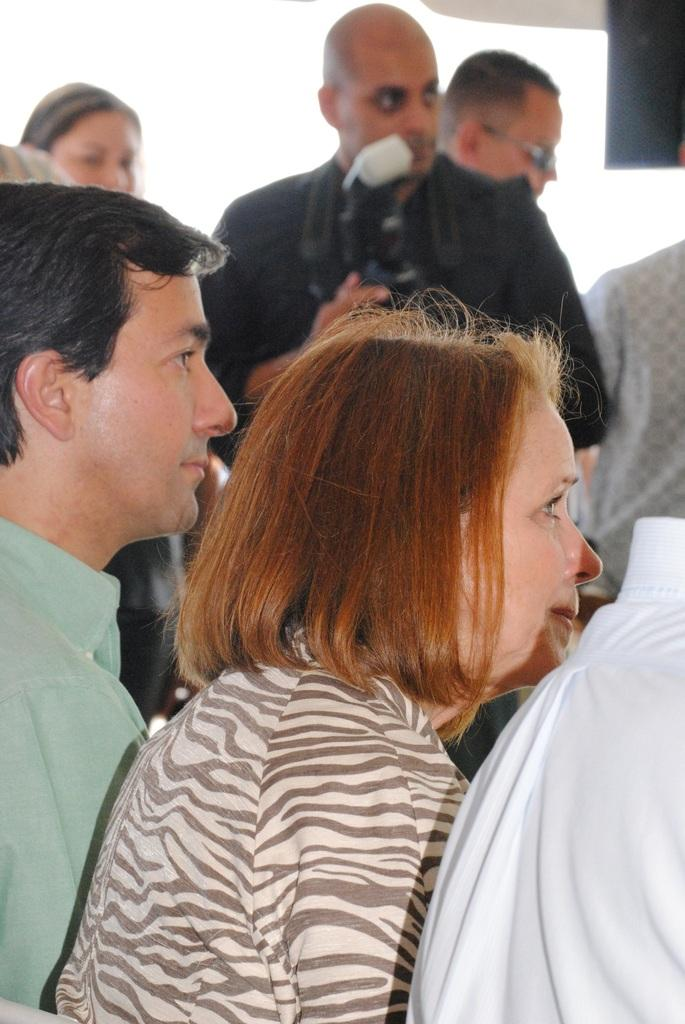How many people are present in the image? There are two people, a man and a woman, present in the image. Where is the man located in the image? The man is in the middle of the picture. What is the man holding in the image? The man is holding a camera. Can you describe the background of the picture? There are people in the background of the picture. What type of vase can be seen on the desk in the image? There is no vase or desk present in the image. How many geese are visible in the image? There are no geese present in the image. 